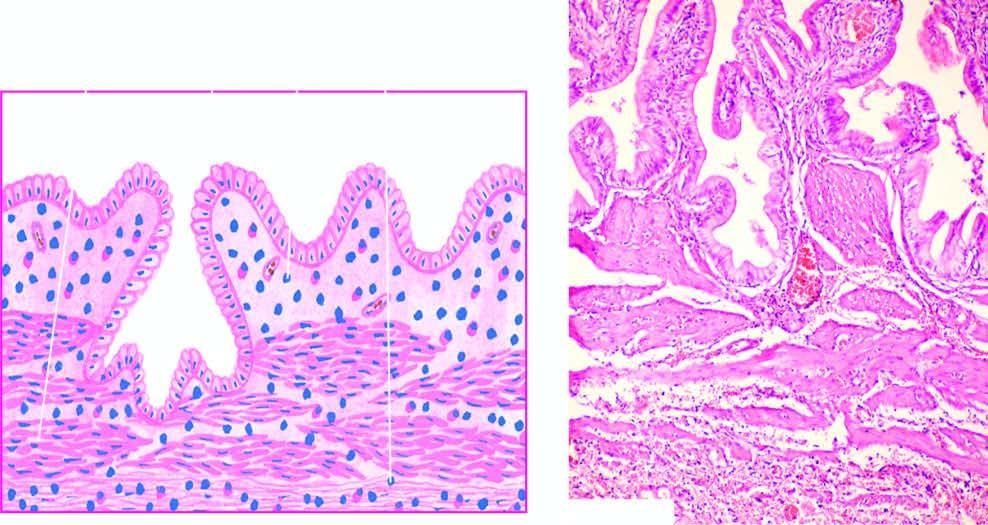what is there of epithelium-lined spaces into the gallbladder wall in an area?
Answer the question using a single word or phrase. Penetration 